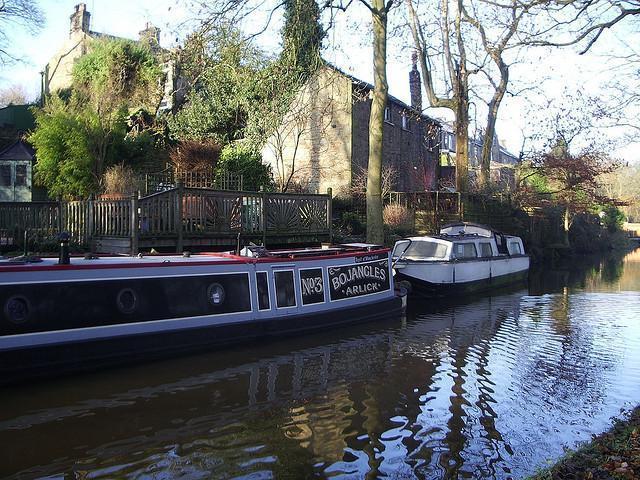How many boats are visible?
Give a very brief answer. 2. 